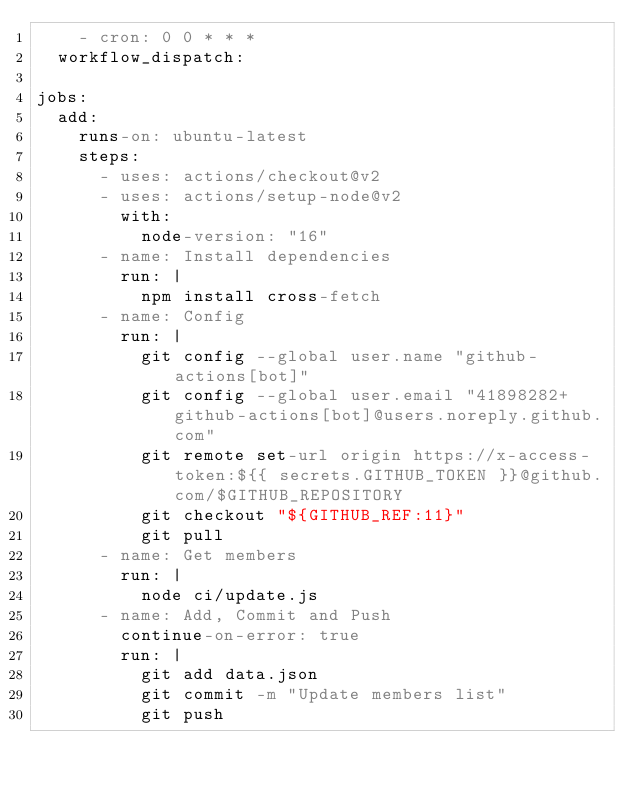<code> <loc_0><loc_0><loc_500><loc_500><_YAML_>    - cron: 0 0 * * *
  workflow_dispatch:

jobs:
  add:
    runs-on: ubuntu-latest
    steps:
      - uses: actions/checkout@v2
      - uses: actions/setup-node@v2
        with:
          node-version: "16"
      - name: Install dependencies
        run: |
          npm install cross-fetch
      - name: Config
        run: |
          git config --global user.name "github-actions[bot]"
          git config --global user.email "41898282+github-actions[bot]@users.noreply.github.com"
          git remote set-url origin https://x-access-token:${{ secrets.GITHUB_TOKEN }}@github.com/$GITHUB_REPOSITORY
          git checkout "${GITHUB_REF:11}"
          git pull
      - name: Get members
        run: |
          node ci/update.js
      - name: Add, Commit and Push
        continue-on-error: true
        run: |
          git add data.json
          git commit -m "Update members list"
          git push
</code> 